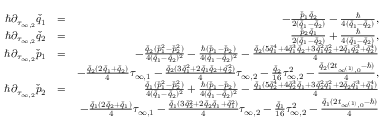Convert formula to latex. <formula><loc_0><loc_0><loc_500><loc_500>\begin{array} { r l r } { \hbar { \partial } _ { \tau _ { \infty , 2 } } \check { q } _ { 1 } } & { = } & { - \frac { \check { p } _ { 1 } \check { q } _ { 2 } } { 2 ( \check { q } _ { 1 } - \check { q } _ { 2 } ) } - \frac { } { 4 ( \check { q } _ { 1 } - \check { q } _ { 2 } ) } , } \\ { \hbar { \partial } _ { \tau _ { \infty , 2 } } \check { q } _ { 2 } } & { = } & { \frac { \check { p } _ { 2 } \check { q } _ { 1 } } { 2 ( \check { q } _ { 1 } - \check { q } _ { 2 } ) } + \frac { } { 4 ( \check { q } _ { 1 } - \check { q } _ { 2 } ) } , } \\ { \hbar { \partial } _ { \tau _ { \infty , 2 } } \check { p } _ { 1 } } & { = } & { - \frac { \check { q } _ { 2 } ( \check { p } _ { 1 } ^ { 2 } - \check { p } _ { 2 } ^ { 2 } ) } { 4 ( \check { q } _ { 1 } - \check { q } _ { 2 } ) ^ { 2 } } - \frac { \hbar { ( } \check { p } _ { 1 } - \check { p } _ { 2 } ) } { 4 ( \check { q } _ { 1 } - \check { q } _ { 2 } ) ^ { 2 } } - \frac { \check { q } _ { 2 } ( 5 \check { q } _ { 1 } ^ { 4 } + 4 \check { q } _ { 1 } ^ { 3 } \check { q } _ { 2 } + 3 \check { q } _ { 1 } ^ { 2 } \check { q } _ { 2 } ^ { 2 } + 2 \check { q } _ { 1 } \check { q } _ { 2 } ^ { 3 } + \check { q } _ { 2 } ^ { 4 } ) } { 4 } } \\ & { - \frac { \check { q } _ { 2 } ( 2 \check { q } _ { 1 } + \check { q } _ { 2 } ) } { 4 } \tau _ { \infty , 1 } - \frac { \check { q } _ { 2 } ( 3 \check { q } _ { 1 } ^ { 2 } + 2 \check { q } _ { 1 } \check { q } _ { 2 } + \check { q } _ { 2 } ^ { 2 } ) } { 4 } \tau _ { \infty , 2 } - \frac { \check { q } _ { 2 } } { 1 6 } \tau _ { \infty , 2 } ^ { 2 } - \frac { \check { q } _ { 2 } ( 2 t _ { \infty ^ { ( 1 ) } , 0 } - \hbar { ) } } { 4 } , } \\ { \hbar { \partial } _ { \tau _ { \infty , 2 } } \check { p } _ { 2 } } & { = } & { \frac { \check { q } _ { 1 } ( \check { p } _ { 1 } ^ { 2 } - \check { p } _ { 2 } ^ { 2 } ) } { 4 ( \check { q } _ { 1 } - \check { q } _ { 2 } ) ^ { 2 } } + \frac { \hbar { ( } \check { p } _ { 1 } - \check { p } _ { 2 } ) } { 4 ( \check { q } _ { 1 } - \check { q } _ { 2 } ) ^ { 2 } } - \frac { \check { q } _ { 1 } ( 5 \check { q } _ { 2 } ^ { 4 } + 4 \check { q } _ { 2 } ^ { 3 } \check { q } _ { 1 } + 3 \check { q } _ { 2 } ^ { 2 } \check { q } _ { 1 } ^ { 2 } + 2 \check { q } _ { 2 } \check { q } _ { 1 } ^ { 3 } + \check { q } _ { 1 } ^ { 4 } ) } { 4 } } \\ & { - \frac { \check { q } _ { 1 } ( 2 \check { q } _ { 2 } + \check { q } _ { 1 } ) } { 4 } \tau _ { \infty , 1 } - \frac { \check { q } _ { 1 } ( 3 \check { q } _ { 2 } ^ { 2 } + 2 \check { q } _ { 2 } \check { q } _ { 1 } + \check { q } _ { 1 } ^ { 2 } ) } { 4 } \tau _ { \infty , 2 } - \frac { \check { q } _ { 1 } } { 1 6 } \tau _ { \infty , 2 } ^ { 2 } - \frac { \check { q } _ { 1 } ( 2 t _ { \infty ^ { ( 1 ) } , 0 } - \hbar { ) } } { 4 } } \\ & \end{array}</formula> 